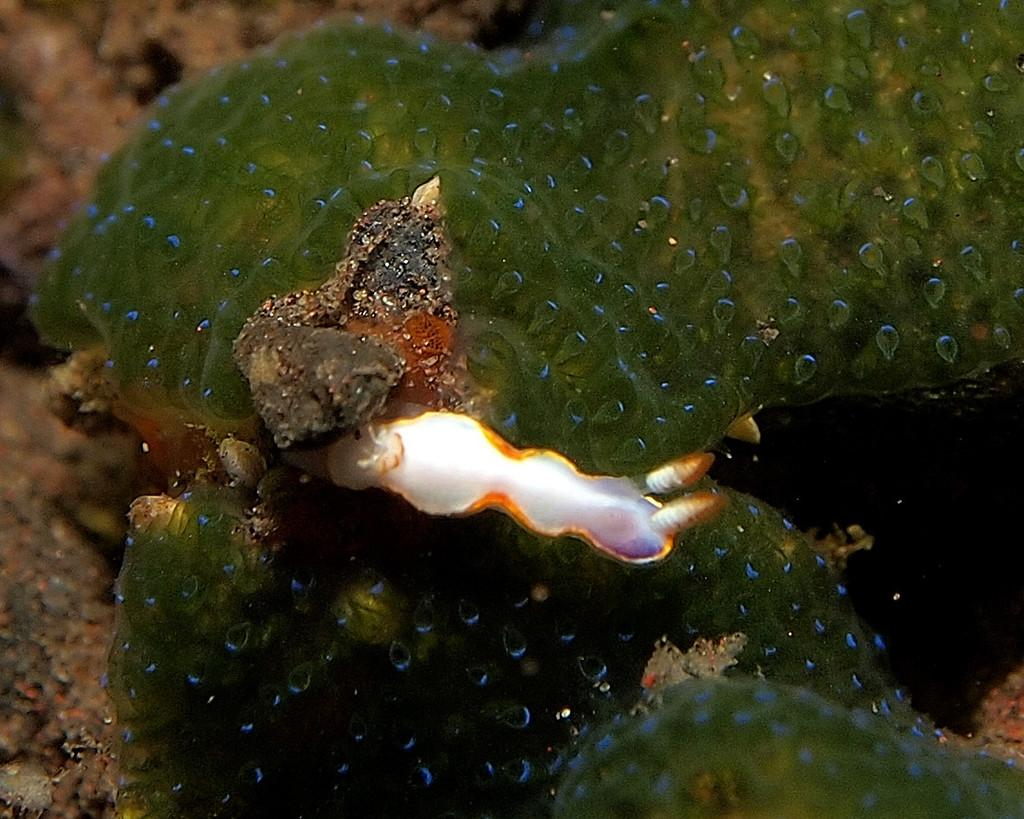What type of animal can be seen in the image? There is a water animal in the image. What type of scarecrow can be seen in the image? There is no scarecrow present in the image; it features a water animal. 